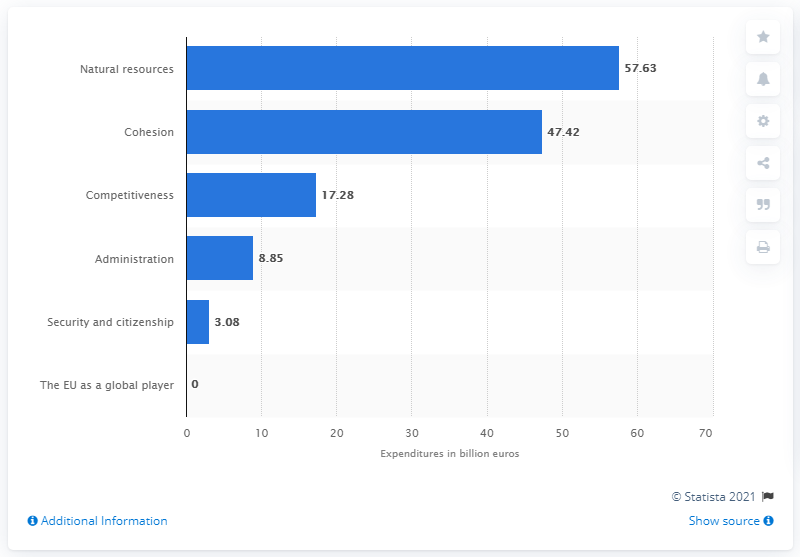Indicate a few pertinent items in this graphic. The amount spent on EU administration in 2019 was 8.85. 